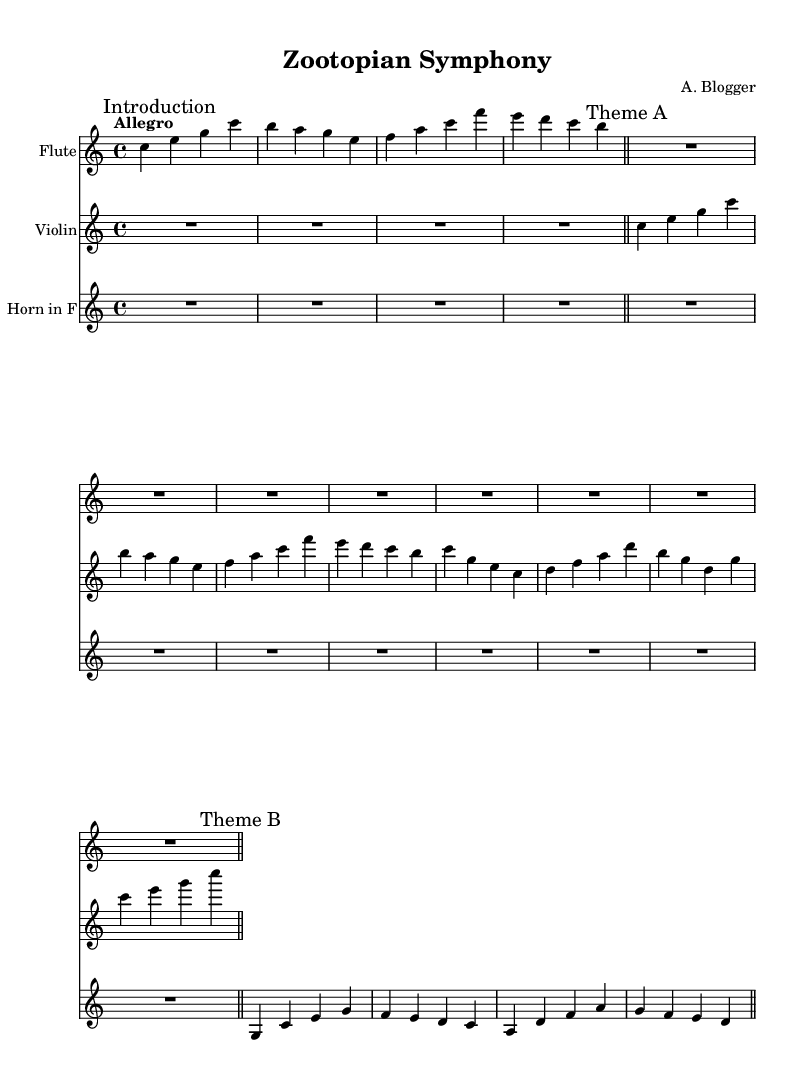What is the key signature of this music? The key signature is C major, which has no sharps or flats.
Answer: C major What is the time signature of the piece? The time signature indicated at the beginning is 4/4, which means there are four beats per measure.
Answer: 4/4 What is the tempo marking for this composition? The tempo marking shown is "Allegro," which indicates a fast and lively tempo.
Answer: Allegro How many measures are in the flute part? Upon counting the measures of the flute part in the sheet music, there are a total of 4 measures.
Answer: 4 Compare the total number of measures in the violin and horn parts. The violin part has 6 measures while the horn part has 4 measures. Adding these gives a total of 10 measures. Thus, the violin part has 2 more measures than the horn part, making it longer.
Answer: Violin: 2 more measures What is the dynamic marking for the violin part? The dynamic marking for the violin part is indicated as "dynamicUp," referring to the dynamics being placed above the staff. This likely suggests the need for a vibrant playing style.
Answer: dynamicUp What is the instrument name for the third staff? The instrument name for the third staff is "Horn in F," which is indicated at the beginning of the staff.
Answer: Horn in F 